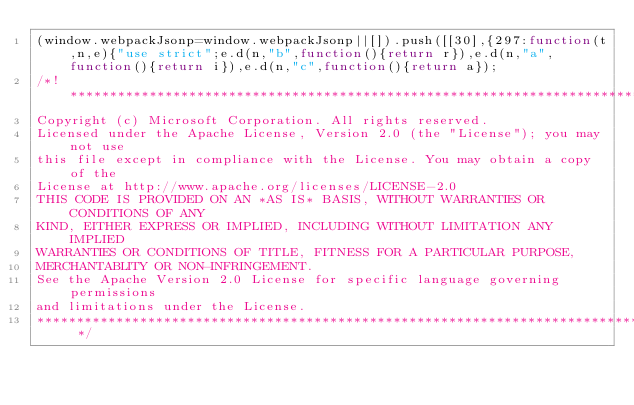Convert code to text. <code><loc_0><loc_0><loc_500><loc_500><_JavaScript_>(window.webpackJsonp=window.webpackJsonp||[]).push([[30],{297:function(t,n,e){"use strict";e.d(n,"b",function(){return r}),e.d(n,"a",function(){return i}),e.d(n,"c",function(){return a});
/*! *****************************************************************************
Copyright (c) Microsoft Corporation. All rights reserved.
Licensed under the Apache License, Version 2.0 (the "License"); you may not use
this file except in compliance with the License. You may obtain a copy of the
License at http://www.apache.org/licenses/LICENSE-2.0
THIS CODE IS PROVIDED ON AN *AS IS* BASIS, WITHOUT WARRANTIES OR CONDITIONS OF ANY
KIND, EITHER EXPRESS OR IMPLIED, INCLUDING WITHOUT LIMITATION ANY IMPLIED
WARRANTIES OR CONDITIONS OF TITLE, FITNESS FOR A PARTICULAR PURPOSE,
MERCHANTABLITY OR NON-INFRINGEMENT.
See the Apache Version 2.0 License for specific language governing permissions
and limitations under the License.
***************************************************************************** */</code> 